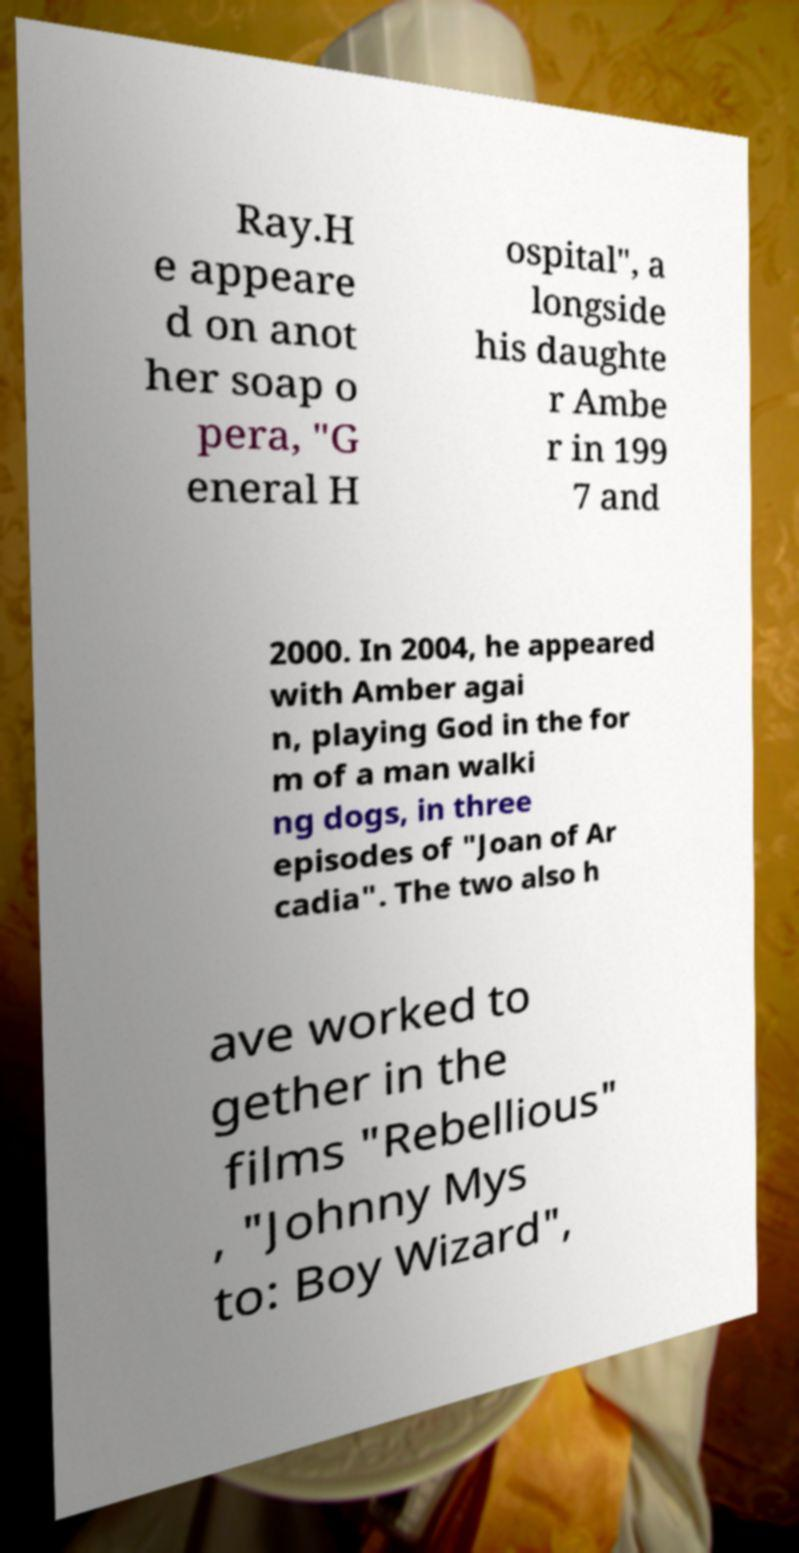There's text embedded in this image that I need extracted. Can you transcribe it verbatim? Ray.H e appeare d on anot her soap o pera, "G eneral H ospital", a longside his daughte r Ambe r in 199 7 and 2000. In 2004, he appeared with Amber agai n, playing God in the for m of a man walki ng dogs, in three episodes of "Joan of Ar cadia". The two also h ave worked to gether in the films "Rebellious" , "Johnny Mys to: Boy Wizard", 